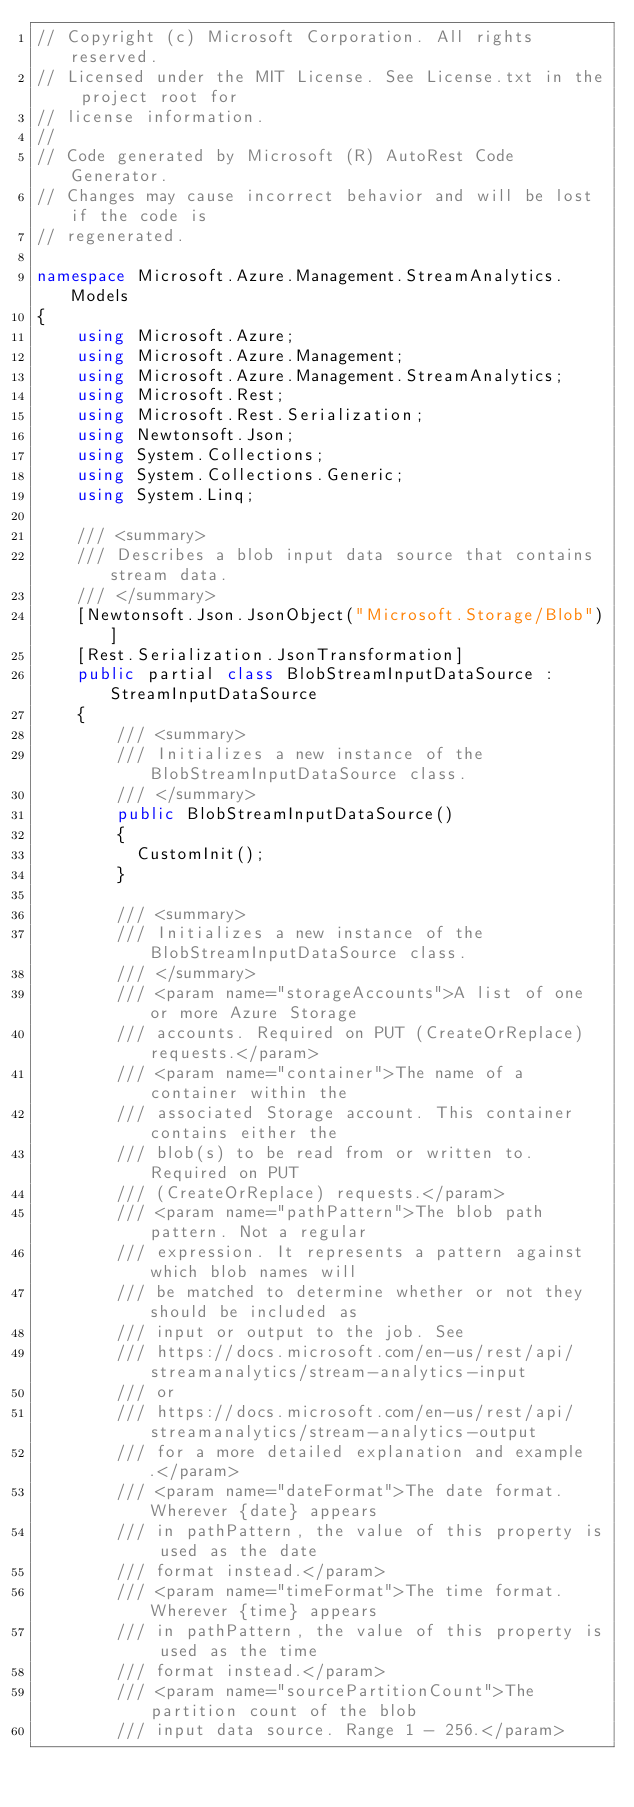Convert code to text. <code><loc_0><loc_0><loc_500><loc_500><_C#_>// Copyright (c) Microsoft Corporation. All rights reserved.
// Licensed under the MIT License. See License.txt in the project root for
// license information.
//
// Code generated by Microsoft (R) AutoRest Code Generator.
// Changes may cause incorrect behavior and will be lost if the code is
// regenerated.

namespace Microsoft.Azure.Management.StreamAnalytics.Models
{
    using Microsoft.Azure;
    using Microsoft.Azure.Management;
    using Microsoft.Azure.Management.StreamAnalytics;
    using Microsoft.Rest;
    using Microsoft.Rest.Serialization;
    using Newtonsoft.Json;
    using System.Collections;
    using System.Collections.Generic;
    using System.Linq;

    /// <summary>
    /// Describes a blob input data source that contains stream data.
    /// </summary>
    [Newtonsoft.Json.JsonObject("Microsoft.Storage/Blob")]
    [Rest.Serialization.JsonTransformation]
    public partial class BlobStreamInputDataSource : StreamInputDataSource
    {
        /// <summary>
        /// Initializes a new instance of the BlobStreamInputDataSource class.
        /// </summary>
        public BlobStreamInputDataSource()
        {
          CustomInit();
        }

        /// <summary>
        /// Initializes a new instance of the BlobStreamInputDataSource class.
        /// </summary>
        /// <param name="storageAccounts">A list of one or more Azure Storage
        /// accounts. Required on PUT (CreateOrReplace) requests.</param>
        /// <param name="container">The name of a container within the
        /// associated Storage account. This container contains either the
        /// blob(s) to be read from or written to. Required on PUT
        /// (CreateOrReplace) requests.</param>
        /// <param name="pathPattern">The blob path pattern. Not a regular
        /// expression. It represents a pattern against which blob names will
        /// be matched to determine whether or not they should be included as
        /// input or output to the job. See
        /// https://docs.microsoft.com/en-us/rest/api/streamanalytics/stream-analytics-input
        /// or
        /// https://docs.microsoft.com/en-us/rest/api/streamanalytics/stream-analytics-output
        /// for a more detailed explanation and example.</param>
        /// <param name="dateFormat">The date format. Wherever {date} appears
        /// in pathPattern, the value of this property is used as the date
        /// format instead.</param>
        /// <param name="timeFormat">The time format. Wherever {time} appears
        /// in pathPattern, the value of this property is used as the time
        /// format instead.</param>
        /// <param name="sourcePartitionCount">The partition count of the blob
        /// input data source. Range 1 - 256.</param></code> 